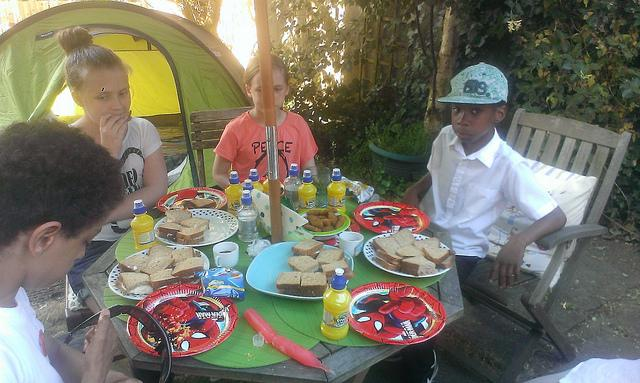What comic brand owns the franchise depicted here? Please explain your reasoning. marvel. Spiderman is on the plates. 